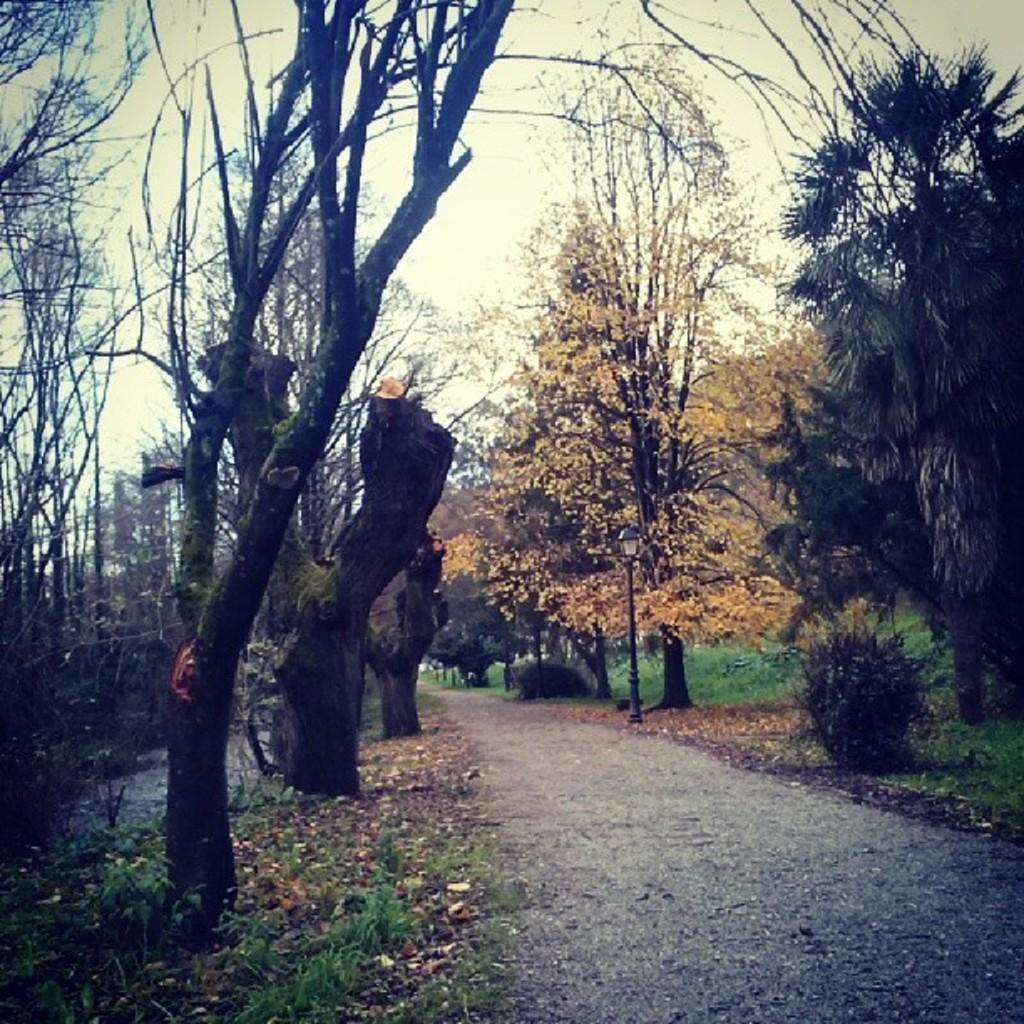What can be seen on the right side of the image? There is a road on the right side of the image. What is visible in the background of the image? There are trees and the sky in the background of the image. What type of terrain is at the bottom of the image? There is grass at the bottom of the image. What type of jail can be seen in the image? There is no jail present in the image. What kind of flesh is visible on the trees in the image? There is no flesh visible on the trees in the image; they are covered with bark and leaves. 